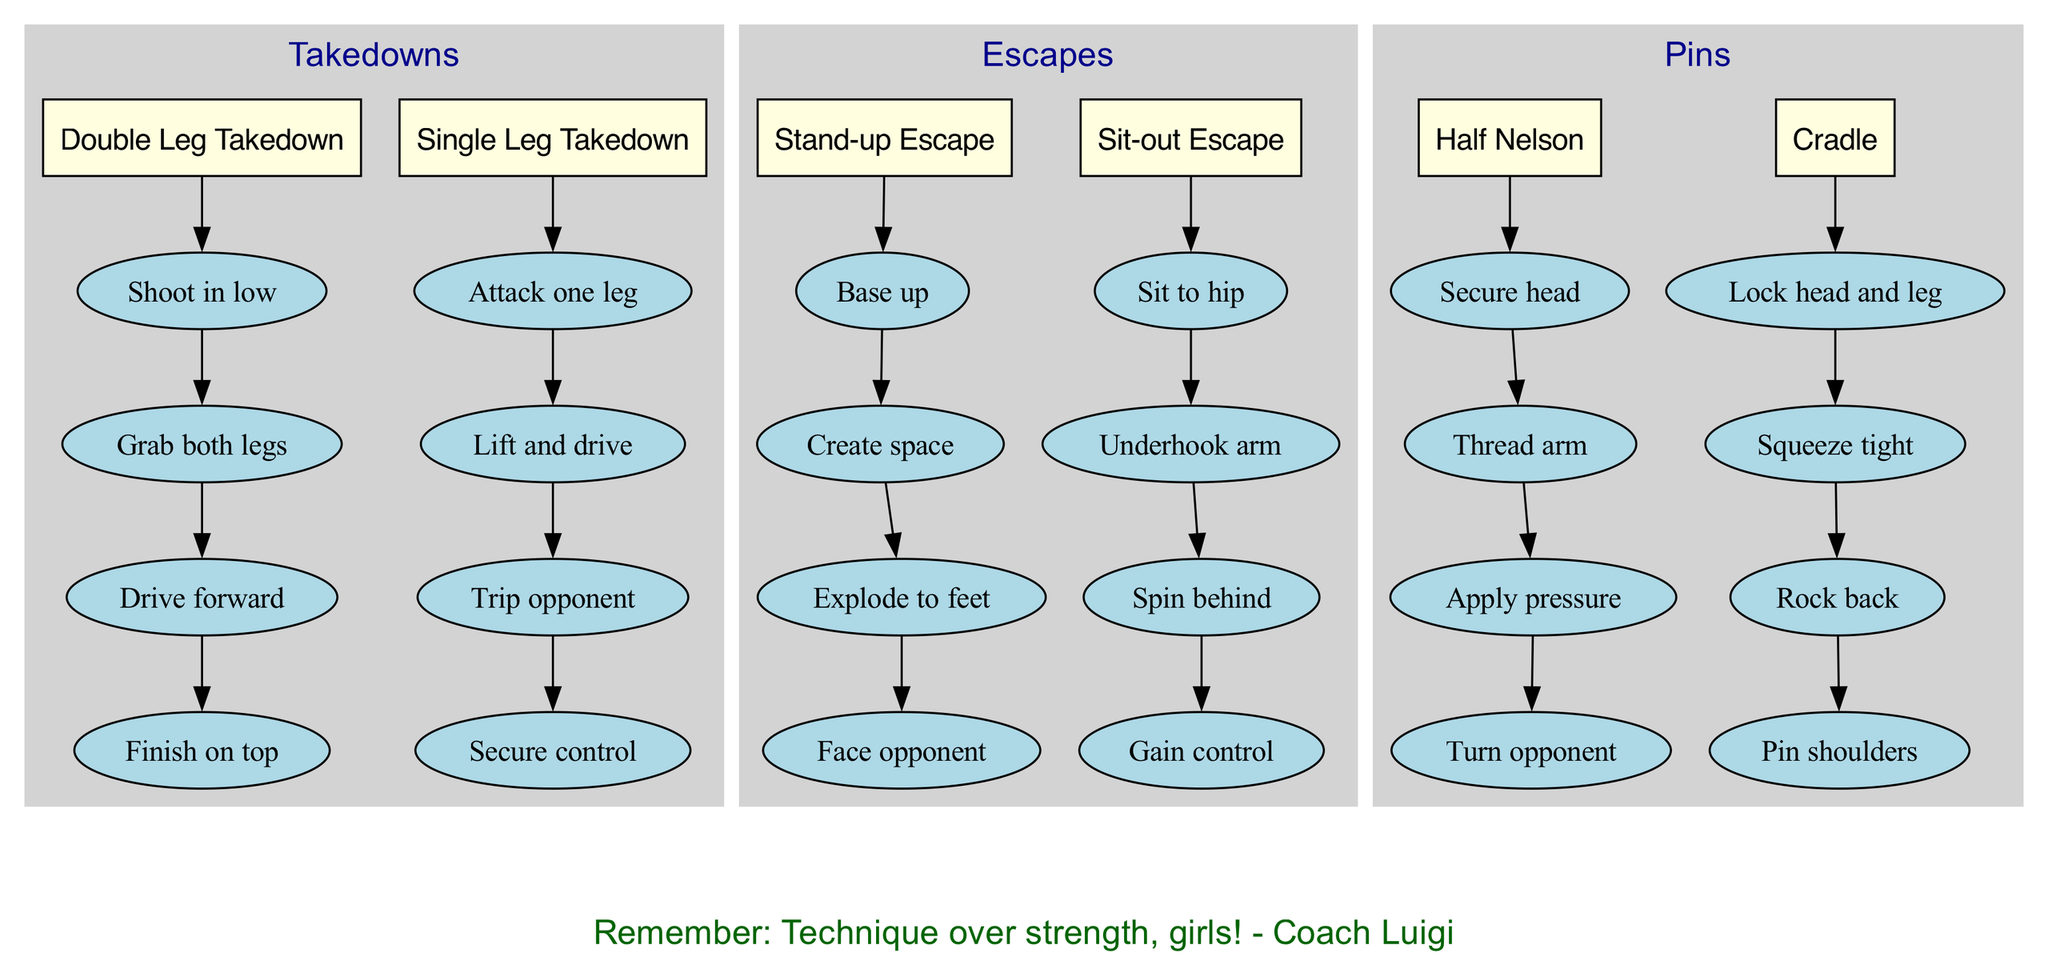What are the two main sections in the diagram? The diagram contains three main sections: "Takedowns," "Escapes," and "Pins." The question asks for two, so any two sections would be correct.
Answer: Takedowns, Escapes How many steps are there in the "Double Leg Takedown"? The "Double Leg Takedown" has four steps clearly listed in the diagram: "Shoot in low," "Grab both legs," "Drive forward," and "Finish on top." Thus, the total number of steps is four.
Answer: 4 Which technique has the first step of "Base up"? "Base up" is the first step in the "Stand-up Escape" technique. Scanning through the techniques in the "Escapes" section shows that it begins with this particular step.
Answer: Stand-up Escape What color are the nodes representing techniques? The nodes for techniques in the diagram are filled with light yellow color, as indicated by the fillcolor attribute set in the code for technique nodes.
Answer: Light yellow In which section would you find the "Cradle"? The "Cradle" technique is located in the "Pins" section. Reviewing the main sections indicates that each has categorized techniques, placing "Cradle" accordingly.
Answer: Pins How many total techniques are illustrated under Takedowns? There are two techniques in the "Takedowns" section: "Double Leg Takedown" and "Single Leg Takedown." Counting these techniques gives the total number in this section.
Answer: 2 What is the last step of the “Half Nelson” technique? The last step of the "Half Nelson" technique is "Turn opponent." This can be found by listing the steps in order and identifying the final one.
Answer: Turn opponent Which escape technique involves spinning behind? The "Sit-out Escape" technique involves "Spin behind" as one of its steps. By reviewing the steps of the techniques in the "Escapes" section, this can be confirmed.
Answer: Sit-out Escape 